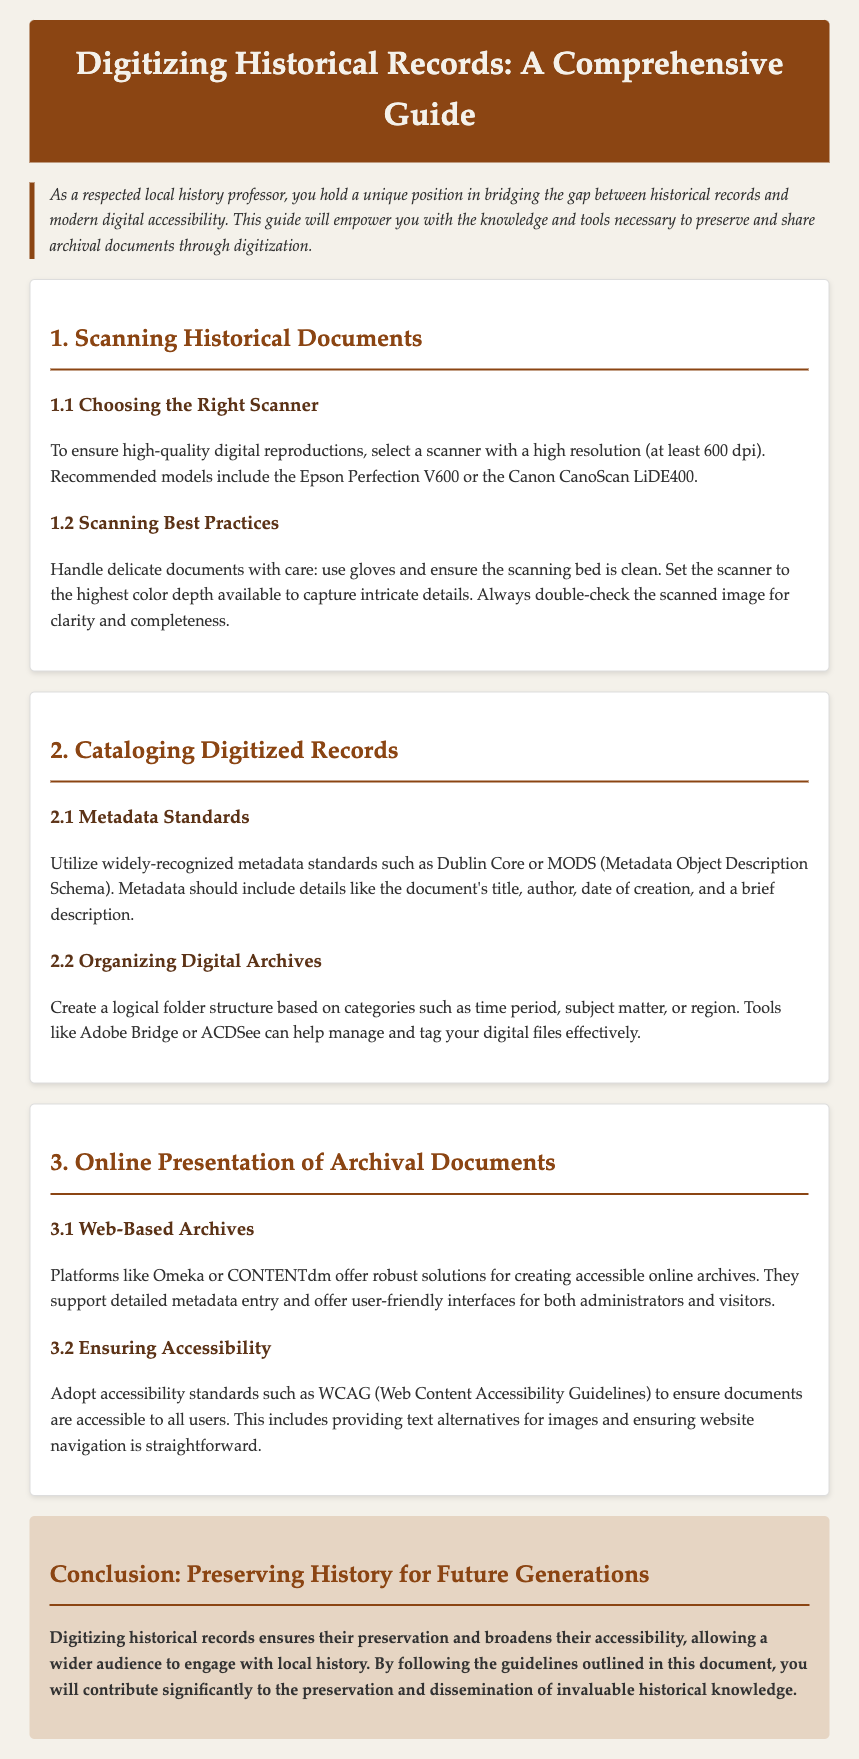What is the minimum recommended scanner resolution? The document states that to ensure high-quality digital reproductions, select a scanner with a high resolution of at least 600 dpi.
Answer: 600 dpi Which two scanner models are recommended? The guide suggests the Epson Perfection V600 and the Canon CanoScan LiDE400 as recommended scanner models.
Answer: Epson Perfection V600, Canon CanoScan LiDE400 What metadata standard is mentioned in the document? The document emphasizes the use of widely-recognized metadata standards like Dublin Core or MODS for cataloging digitized records.
Answer: Dublin Core What should be included in the metadata? The document indicates that metadata should include details such as the document's title, author, date of creation, and a brief description.
Answer: Title, author, date of creation, brief description What software is suggested for managing digital files? The guide mentions that tools like Adobe Bridge or ACDSee can help manage and tag digital files effectively.
Answer: Adobe Bridge, ACDSee What accessibility standard should be adopted for online documents? The document states to adopt accessibility standards such as WCAG to ensure documents are accessible to all users.
Answer: WCAG What is the primary purpose of digitizing historical records? The document concludes that digitizing historical records ensures their preservation and broadens their accessibility for a wider audience.
Answer: Preservation and accessibility What is one platform mentioned for creating online archives? The guide lists platforms such as Omeka or CONTENTdm that offer robust solutions for creating accessible online archives.
Answer: Omeka Who is the target audience for this guide? The introduction clearly states the target audience as local history professors seeking to bridge the gap between historical records and digital accessibility.
Answer: Local history professors 